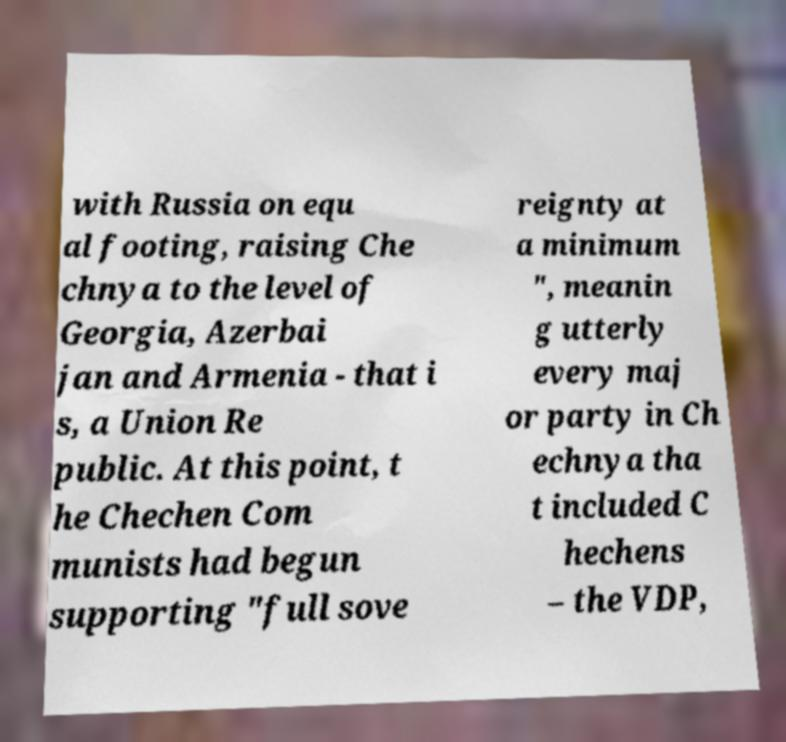Could you assist in decoding the text presented in this image and type it out clearly? with Russia on equ al footing, raising Che chnya to the level of Georgia, Azerbai jan and Armenia - that i s, a Union Re public. At this point, t he Chechen Com munists had begun supporting "full sove reignty at a minimum ", meanin g utterly every maj or party in Ch echnya tha t included C hechens – the VDP, 